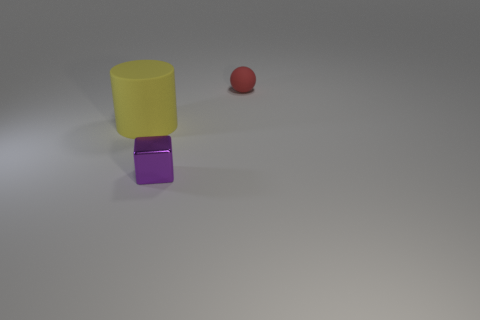Is there any other thing that is the same material as the small cube?
Offer a very short reply. No. There is a matte ball that is the same size as the purple metallic cube; what color is it?
Keep it short and to the point. Red. Do the matte thing that is right of the tiny purple metal object and the big thing have the same shape?
Offer a very short reply. No. What color is the object that is left of the tiny thing that is in front of the matte thing on the right side of the purple metallic block?
Give a very brief answer. Yellow. Are any big purple cylinders visible?
Offer a terse response. No. What number of other objects are the same size as the purple metallic block?
Offer a very short reply. 1. There is a small shiny thing; is it the same color as the rubber object on the left side of the small ball?
Provide a succinct answer. No. What number of things are either yellow shiny blocks or tiny blocks?
Your answer should be compact. 1. Is there anything else that has the same color as the tiny rubber thing?
Your answer should be very brief. No. Is the small ball made of the same material as the thing in front of the large yellow object?
Offer a very short reply. No. 